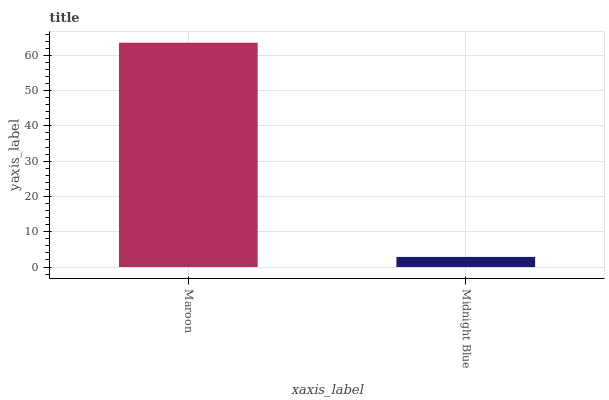Is Midnight Blue the minimum?
Answer yes or no. Yes. Is Maroon the maximum?
Answer yes or no. Yes. Is Midnight Blue the maximum?
Answer yes or no. No. Is Maroon greater than Midnight Blue?
Answer yes or no. Yes. Is Midnight Blue less than Maroon?
Answer yes or no. Yes. Is Midnight Blue greater than Maroon?
Answer yes or no. No. Is Maroon less than Midnight Blue?
Answer yes or no. No. Is Maroon the high median?
Answer yes or no. Yes. Is Midnight Blue the low median?
Answer yes or no. Yes. Is Midnight Blue the high median?
Answer yes or no. No. Is Maroon the low median?
Answer yes or no. No. 